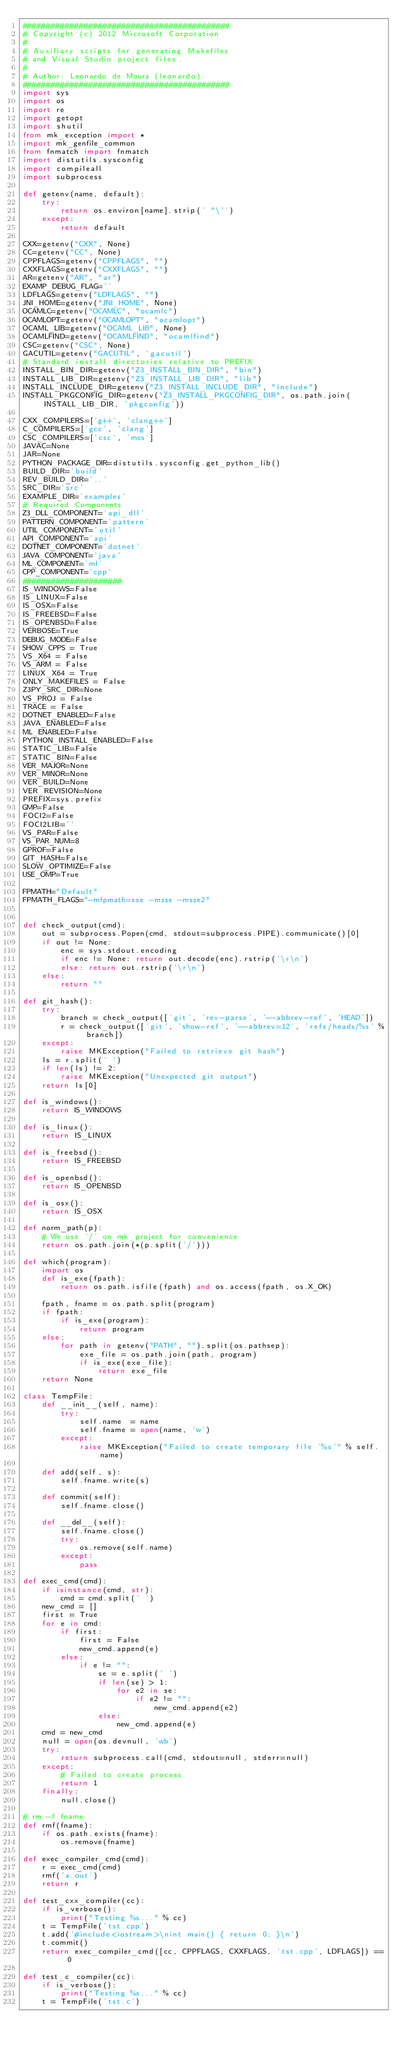<code> <loc_0><loc_0><loc_500><loc_500><_Python_>############################################
# Copyright (c) 2012 Microsoft Corporation
#
# Auxiliary scripts for generating Makefiles
# and Visual Studio project files.
#
# Author: Leonardo de Moura (leonardo)
############################################
import sys
import os
import re
import getopt
import shutil
from mk_exception import *
import mk_genfile_common
from fnmatch import fnmatch
import distutils.sysconfig
import compileall
import subprocess

def getenv(name, default):
    try:
        return os.environ[name].strip(' "\'')
    except:
        return default

CXX=getenv("CXX", None)
CC=getenv("CC", None)
CPPFLAGS=getenv("CPPFLAGS", "")
CXXFLAGS=getenv("CXXFLAGS", "")
AR=getenv("AR", "ar")
EXAMP_DEBUG_FLAG=''
LDFLAGS=getenv("LDFLAGS", "")
JNI_HOME=getenv("JNI_HOME", None)
OCAMLC=getenv("OCAMLC", "ocamlc")
OCAMLOPT=getenv("OCAMLOPT", "ocamlopt")
OCAML_LIB=getenv("OCAML_LIB", None)
OCAMLFIND=getenv("OCAMLFIND", "ocamlfind")
CSC=getenv("CSC", None)
GACUTIL=getenv("GACUTIL", 'gacutil')
# Standard install directories relative to PREFIX
INSTALL_BIN_DIR=getenv("Z3_INSTALL_BIN_DIR", "bin")
INSTALL_LIB_DIR=getenv("Z3_INSTALL_LIB_DIR", "lib")
INSTALL_INCLUDE_DIR=getenv("Z3_INSTALL_INCLUDE_DIR", "include")
INSTALL_PKGCONFIG_DIR=getenv("Z3_INSTALL_PKGCONFIG_DIR", os.path.join(INSTALL_LIB_DIR, 'pkgconfig'))

CXX_COMPILERS=['g++', 'clang++']
C_COMPILERS=['gcc', 'clang']
CSC_COMPILERS=['csc', 'mcs']
JAVAC=None
JAR=None
PYTHON_PACKAGE_DIR=distutils.sysconfig.get_python_lib()
BUILD_DIR='build'
REV_BUILD_DIR='..'
SRC_DIR='src'
EXAMPLE_DIR='examples'
# Required Components
Z3_DLL_COMPONENT='api_dll'
PATTERN_COMPONENT='pattern'
UTIL_COMPONENT='util'
API_COMPONENT='api'
DOTNET_COMPONENT='dotnet'
JAVA_COMPONENT='java'
ML_COMPONENT='ml'
CPP_COMPONENT='cpp'
#####################
IS_WINDOWS=False
IS_LINUX=False
IS_OSX=False
IS_FREEBSD=False
IS_OPENBSD=False
VERBOSE=True
DEBUG_MODE=False
SHOW_CPPS = True
VS_X64 = False
VS_ARM = False
LINUX_X64 = True
ONLY_MAKEFILES = False
Z3PY_SRC_DIR=None
VS_PROJ = False
TRACE = False
DOTNET_ENABLED=False
JAVA_ENABLED=False
ML_ENABLED=False
PYTHON_INSTALL_ENABLED=False
STATIC_LIB=False
STATIC_BIN=False
VER_MAJOR=None
VER_MINOR=None
VER_BUILD=None
VER_REVISION=None
PREFIX=sys.prefix
GMP=False
FOCI2=False
FOCI2LIB=''
VS_PAR=False
VS_PAR_NUM=8
GPROF=False
GIT_HASH=False
SLOW_OPTIMIZE=False
USE_OMP=True

FPMATH="Default"
FPMATH_FLAGS="-mfpmath=sse -msse -msse2"


def check_output(cmd):
    out = subprocess.Popen(cmd, stdout=subprocess.PIPE).communicate()[0]
    if out != None:
        enc = sys.stdout.encoding
        if enc != None: return out.decode(enc).rstrip('\r\n')
        else: return out.rstrip('\r\n')
    else:
        return ""

def git_hash():
    try:
        branch = check_output(['git', 'rev-parse', '--abbrev-ref', 'HEAD'])
        r = check_output(['git', 'show-ref', '--abbrev=12', 'refs/heads/%s' % branch])
    except:
        raise MKException("Failed to retrieve git hash")
    ls = r.split(' ')
    if len(ls) != 2:
        raise MKException("Unexpected git output")
    return ls[0]

def is_windows():
    return IS_WINDOWS

def is_linux():
    return IS_LINUX

def is_freebsd():
    return IS_FREEBSD

def is_openbsd():
    return IS_OPENBSD

def is_osx():
    return IS_OSX

def norm_path(p):
    # We use '/' on mk_project for convenience
    return os.path.join(*(p.split('/')))

def which(program):
    import os
    def is_exe(fpath):
        return os.path.isfile(fpath) and os.access(fpath, os.X_OK)

    fpath, fname = os.path.split(program)
    if fpath:
        if is_exe(program):
            return program
    else:
        for path in getenv("PATH", "").split(os.pathsep):
            exe_file = os.path.join(path, program)
            if is_exe(exe_file):
                return exe_file
    return None

class TempFile:
    def __init__(self, name):
        try:
            self.name  = name
            self.fname = open(name, 'w')
        except:
            raise MKException("Failed to create temporary file '%s'" % self.name)

    def add(self, s):
        self.fname.write(s)

    def commit(self):
        self.fname.close()

    def __del__(self):
        self.fname.close()
        try:
            os.remove(self.name)
        except:
            pass

def exec_cmd(cmd):
    if isinstance(cmd, str):
        cmd = cmd.split(' ')
    new_cmd = []
    first = True
    for e in cmd:
        if first:
            first = False
            new_cmd.append(e)
        else:
            if e != "":
                se = e.split(' ')
                if len(se) > 1:
                    for e2 in se:
                        if e2 != "":
                            new_cmd.append(e2)
                else:
                    new_cmd.append(e)
    cmd = new_cmd
    null = open(os.devnull, 'wb')
    try:
        return subprocess.call(cmd, stdout=null, stderr=null)
    except:
        # Failed to create process
        return 1
    finally:
        null.close()

# rm -f fname
def rmf(fname):
    if os.path.exists(fname):
        os.remove(fname)

def exec_compiler_cmd(cmd):
    r = exec_cmd(cmd)
    rmf('a.out')
    return r

def test_cxx_compiler(cc):
    if is_verbose():
        print("Testing %s..." % cc)
    t = TempFile('tst.cpp')
    t.add('#include<iostream>\nint main() { return 0; }\n')
    t.commit()
    return exec_compiler_cmd([cc, CPPFLAGS, CXXFLAGS, 'tst.cpp', LDFLAGS]) == 0

def test_c_compiler(cc):
    if is_verbose():
        print("Testing %s..." % cc)
    t = TempFile('tst.c')</code> 